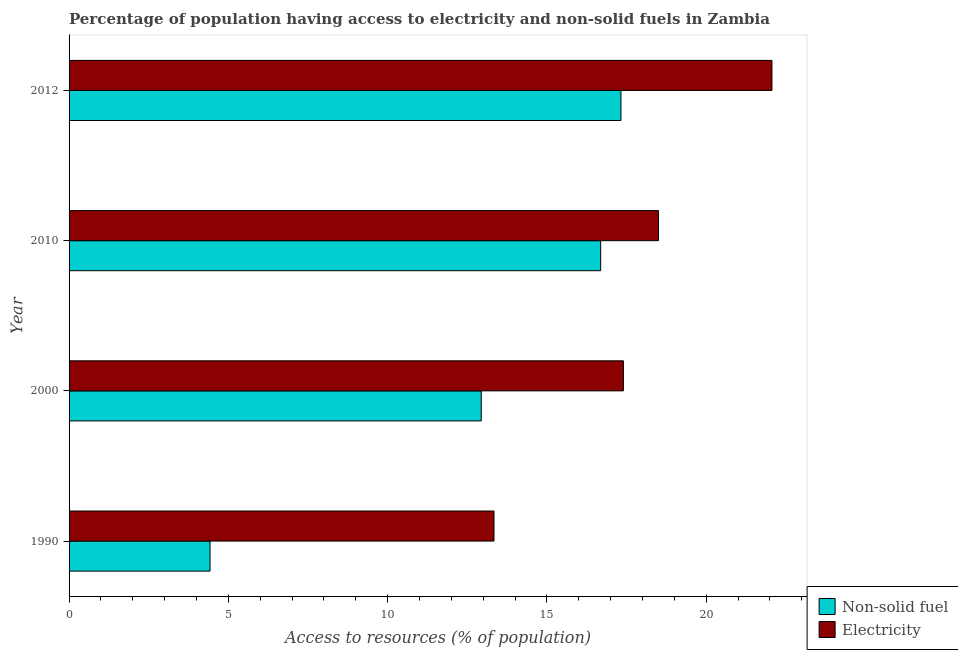How many different coloured bars are there?
Provide a succinct answer. 2. How many groups of bars are there?
Make the answer very short. 4. Are the number of bars per tick equal to the number of legend labels?
Your response must be concise. Yes. Are the number of bars on each tick of the Y-axis equal?
Your answer should be very brief. Yes. How many bars are there on the 3rd tick from the top?
Keep it short and to the point. 2. How many bars are there on the 4th tick from the bottom?
Provide a succinct answer. 2. What is the label of the 3rd group of bars from the top?
Offer a terse response. 2000. What is the percentage of population having access to electricity in 2012?
Offer a very short reply. 22.06. Across all years, what is the maximum percentage of population having access to non-solid fuel?
Your response must be concise. 17.32. Across all years, what is the minimum percentage of population having access to non-solid fuel?
Give a very brief answer. 4.42. In which year was the percentage of population having access to electricity maximum?
Your answer should be compact. 2012. What is the total percentage of population having access to electricity in the graph?
Your answer should be compact. 71.3. What is the difference between the percentage of population having access to electricity in 1990 and that in 2010?
Make the answer very short. -5.16. What is the difference between the percentage of population having access to non-solid fuel in 2010 and the percentage of population having access to electricity in 1990?
Give a very brief answer. 3.35. What is the average percentage of population having access to electricity per year?
Your answer should be compact. 17.82. In the year 2010, what is the difference between the percentage of population having access to non-solid fuel and percentage of population having access to electricity?
Provide a short and direct response. -1.81. What is the ratio of the percentage of population having access to electricity in 2000 to that in 2010?
Keep it short and to the point. 0.94. Is the difference between the percentage of population having access to electricity in 2000 and 2010 greater than the difference between the percentage of population having access to non-solid fuel in 2000 and 2010?
Offer a terse response. Yes. What is the difference between the highest and the second highest percentage of population having access to electricity?
Make the answer very short. 3.56. What is the difference between the highest and the lowest percentage of population having access to electricity?
Offer a very short reply. 8.72. Is the sum of the percentage of population having access to non-solid fuel in 1990 and 2012 greater than the maximum percentage of population having access to electricity across all years?
Keep it short and to the point. No. What does the 2nd bar from the top in 1990 represents?
Your answer should be compact. Non-solid fuel. What does the 1st bar from the bottom in 2012 represents?
Provide a short and direct response. Non-solid fuel. How many bars are there?
Your answer should be very brief. 8. Are all the bars in the graph horizontal?
Ensure brevity in your answer.  Yes. Are the values on the major ticks of X-axis written in scientific E-notation?
Your answer should be very brief. No. Where does the legend appear in the graph?
Make the answer very short. Bottom right. How many legend labels are there?
Keep it short and to the point. 2. How are the legend labels stacked?
Your answer should be compact. Vertical. What is the title of the graph?
Provide a short and direct response. Percentage of population having access to electricity and non-solid fuels in Zambia. What is the label or title of the X-axis?
Your answer should be very brief. Access to resources (% of population). What is the label or title of the Y-axis?
Make the answer very short. Year. What is the Access to resources (% of population) of Non-solid fuel in 1990?
Keep it short and to the point. 4.42. What is the Access to resources (% of population) in Electricity in 1990?
Offer a very short reply. 13.34. What is the Access to resources (% of population) in Non-solid fuel in 2000?
Offer a very short reply. 12.94. What is the Access to resources (% of population) in Electricity in 2000?
Your answer should be compact. 17.4. What is the Access to resources (% of population) of Non-solid fuel in 2010?
Keep it short and to the point. 16.69. What is the Access to resources (% of population) of Non-solid fuel in 2012?
Offer a very short reply. 17.32. What is the Access to resources (% of population) of Electricity in 2012?
Your answer should be very brief. 22.06. Across all years, what is the maximum Access to resources (% of population) of Non-solid fuel?
Make the answer very short. 17.32. Across all years, what is the maximum Access to resources (% of population) of Electricity?
Your response must be concise. 22.06. Across all years, what is the minimum Access to resources (% of population) in Non-solid fuel?
Offer a very short reply. 4.42. Across all years, what is the minimum Access to resources (% of population) in Electricity?
Make the answer very short. 13.34. What is the total Access to resources (% of population) in Non-solid fuel in the graph?
Provide a short and direct response. 51.37. What is the total Access to resources (% of population) of Electricity in the graph?
Your answer should be compact. 71.3. What is the difference between the Access to resources (% of population) in Non-solid fuel in 1990 and that in 2000?
Offer a very short reply. -8.51. What is the difference between the Access to resources (% of population) in Electricity in 1990 and that in 2000?
Ensure brevity in your answer.  -4.06. What is the difference between the Access to resources (% of population) in Non-solid fuel in 1990 and that in 2010?
Provide a succinct answer. -12.26. What is the difference between the Access to resources (% of population) of Electricity in 1990 and that in 2010?
Your answer should be compact. -5.16. What is the difference between the Access to resources (% of population) in Non-solid fuel in 1990 and that in 2012?
Your response must be concise. -12.9. What is the difference between the Access to resources (% of population) of Electricity in 1990 and that in 2012?
Your response must be concise. -8.72. What is the difference between the Access to resources (% of population) in Non-solid fuel in 2000 and that in 2010?
Keep it short and to the point. -3.75. What is the difference between the Access to resources (% of population) in Non-solid fuel in 2000 and that in 2012?
Provide a succinct answer. -4.38. What is the difference between the Access to resources (% of population) in Electricity in 2000 and that in 2012?
Keep it short and to the point. -4.66. What is the difference between the Access to resources (% of population) in Non-solid fuel in 2010 and that in 2012?
Keep it short and to the point. -0.64. What is the difference between the Access to resources (% of population) of Electricity in 2010 and that in 2012?
Your answer should be very brief. -3.56. What is the difference between the Access to resources (% of population) in Non-solid fuel in 1990 and the Access to resources (% of population) in Electricity in 2000?
Provide a short and direct response. -12.97. What is the difference between the Access to resources (% of population) of Non-solid fuel in 1990 and the Access to resources (% of population) of Electricity in 2010?
Keep it short and to the point. -14.07. What is the difference between the Access to resources (% of population) of Non-solid fuel in 1990 and the Access to resources (% of population) of Electricity in 2012?
Offer a terse response. -17.64. What is the difference between the Access to resources (% of population) in Non-solid fuel in 2000 and the Access to resources (% of population) in Electricity in 2010?
Ensure brevity in your answer.  -5.56. What is the difference between the Access to resources (% of population) in Non-solid fuel in 2000 and the Access to resources (% of population) in Electricity in 2012?
Keep it short and to the point. -9.12. What is the difference between the Access to resources (% of population) in Non-solid fuel in 2010 and the Access to resources (% of population) in Electricity in 2012?
Make the answer very short. -5.38. What is the average Access to resources (% of population) of Non-solid fuel per year?
Your answer should be compact. 12.84. What is the average Access to resources (% of population) of Electricity per year?
Offer a terse response. 17.83. In the year 1990, what is the difference between the Access to resources (% of population) of Non-solid fuel and Access to resources (% of population) of Electricity?
Make the answer very short. -8.91. In the year 2000, what is the difference between the Access to resources (% of population) of Non-solid fuel and Access to resources (% of population) of Electricity?
Offer a terse response. -4.46. In the year 2010, what is the difference between the Access to resources (% of population) of Non-solid fuel and Access to resources (% of population) of Electricity?
Your response must be concise. -1.81. In the year 2012, what is the difference between the Access to resources (% of population) of Non-solid fuel and Access to resources (% of population) of Electricity?
Give a very brief answer. -4.74. What is the ratio of the Access to resources (% of population) in Non-solid fuel in 1990 to that in 2000?
Offer a terse response. 0.34. What is the ratio of the Access to resources (% of population) of Electricity in 1990 to that in 2000?
Ensure brevity in your answer.  0.77. What is the ratio of the Access to resources (% of population) in Non-solid fuel in 1990 to that in 2010?
Provide a succinct answer. 0.27. What is the ratio of the Access to resources (% of population) of Electricity in 1990 to that in 2010?
Provide a short and direct response. 0.72. What is the ratio of the Access to resources (% of population) of Non-solid fuel in 1990 to that in 2012?
Give a very brief answer. 0.26. What is the ratio of the Access to resources (% of population) in Electricity in 1990 to that in 2012?
Offer a terse response. 0.6. What is the ratio of the Access to resources (% of population) in Non-solid fuel in 2000 to that in 2010?
Your answer should be compact. 0.78. What is the ratio of the Access to resources (% of population) in Electricity in 2000 to that in 2010?
Provide a short and direct response. 0.94. What is the ratio of the Access to resources (% of population) of Non-solid fuel in 2000 to that in 2012?
Provide a succinct answer. 0.75. What is the ratio of the Access to resources (% of population) of Electricity in 2000 to that in 2012?
Provide a short and direct response. 0.79. What is the ratio of the Access to resources (% of population) of Non-solid fuel in 2010 to that in 2012?
Your response must be concise. 0.96. What is the ratio of the Access to resources (% of population) of Electricity in 2010 to that in 2012?
Ensure brevity in your answer.  0.84. What is the difference between the highest and the second highest Access to resources (% of population) in Non-solid fuel?
Provide a succinct answer. 0.64. What is the difference between the highest and the second highest Access to resources (% of population) in Electricity?
Provide a succinct answer. 3.56. What is the difference between the highest and the lowest Access to resources (% of population) of Non-solid fuel?
Offer a terse response. 12.9. What is the difference between the highest and the lowest Access to resources (% of population) in Electricity?
Offer a very short reply. 8.72. 